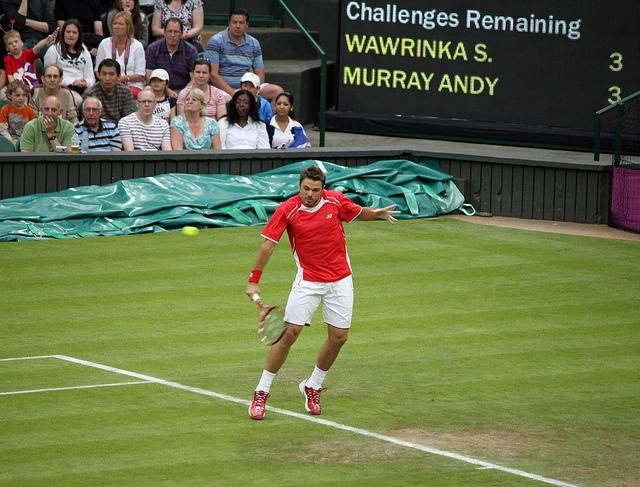What type of sign is shown?

Choices:
A) scoreboard
B) warning
C) brand
D) regulatory scoreboard 